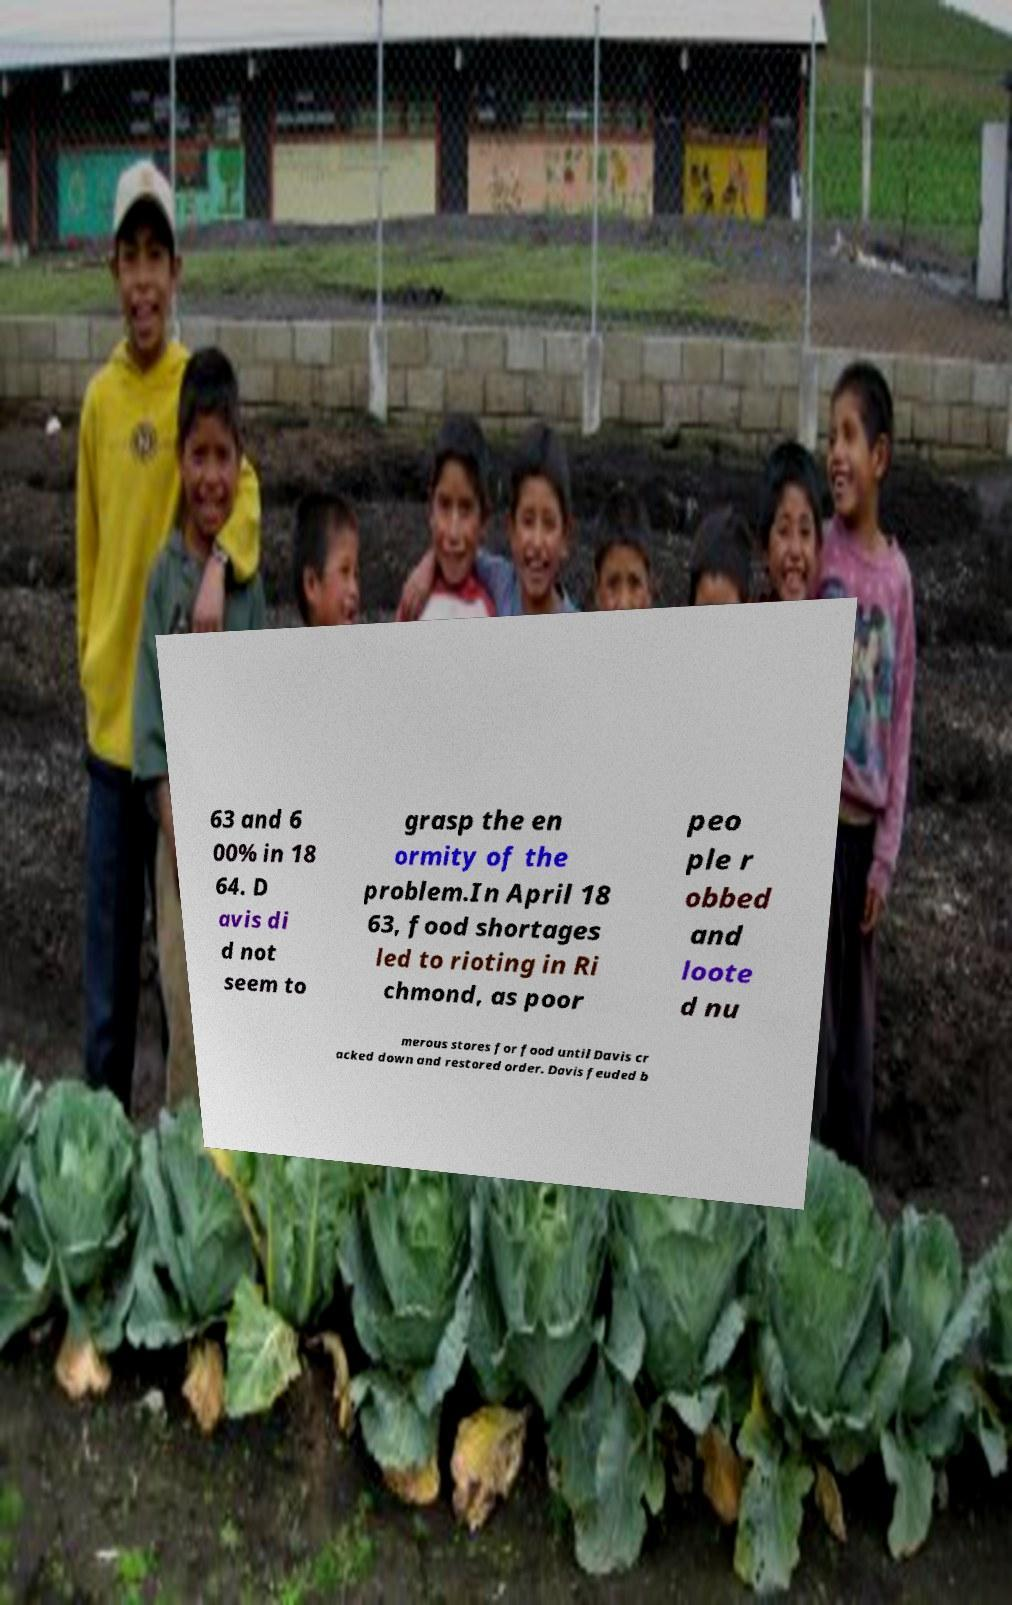Please identify and transcribe the text found in this image. 63 and 6 00% in 18 64. D avis di d not seem to grasp the en ormity of the problem.In April 18 63, food shortages led to rioting in Ri chmond, as poor peo ple r obbed and loote d nu merous stores for food until Davis cr acked down and restored order. Davis feuded b 